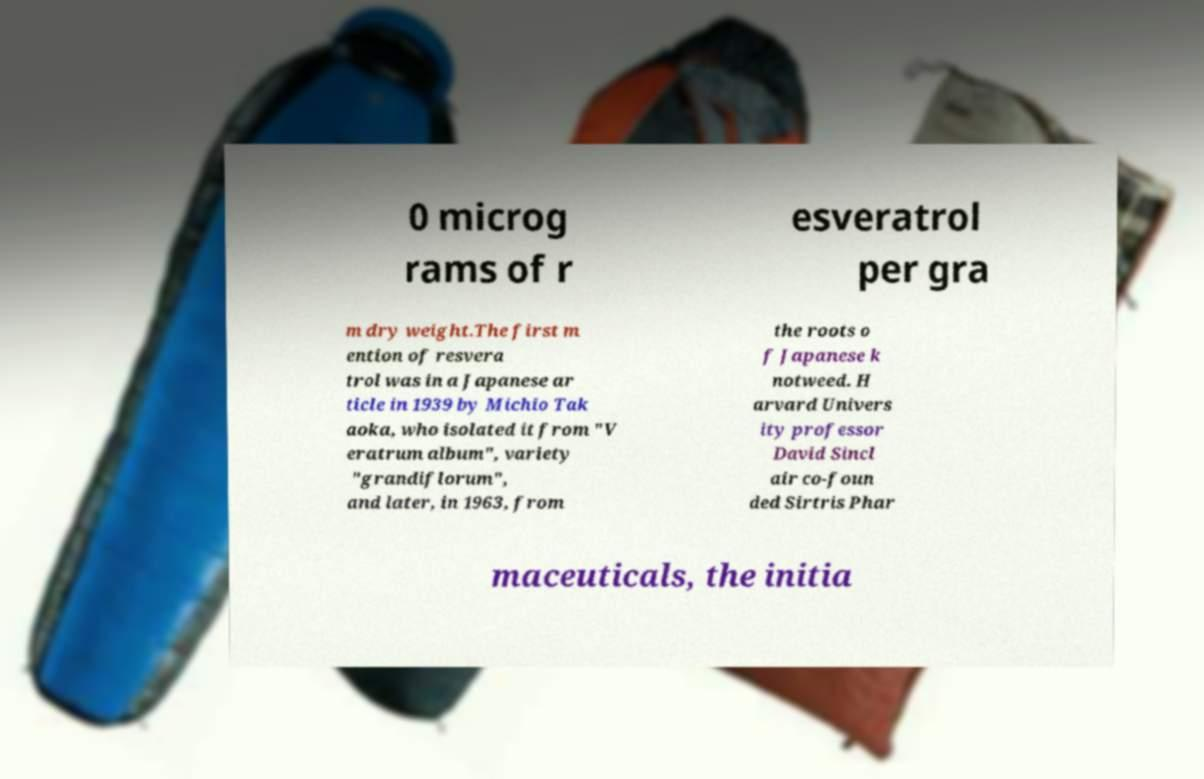I need the written content from this picture converted into text. Can you do that? 0 microg rams of r esveratrol per gra m dry weight.The first m ention of resvera trol was in a Japanese ar ticle in 1939 by Michio Tak aoka, who isolated it from "V eratrum album", variety "grandiflorum", and later, in 1963, from the roots o f Japanese k notweed. H arvard Univers ity professor David Sincl air co-foun ded Sirtris Phar maceuticals, the initia 